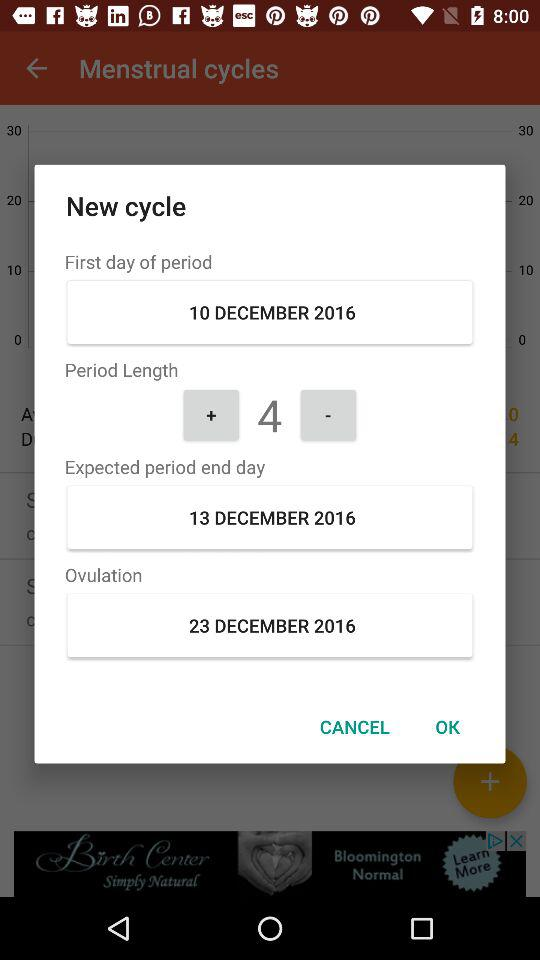What is the expected end date of the period? The expected end date of the period is December 13, 2016. 